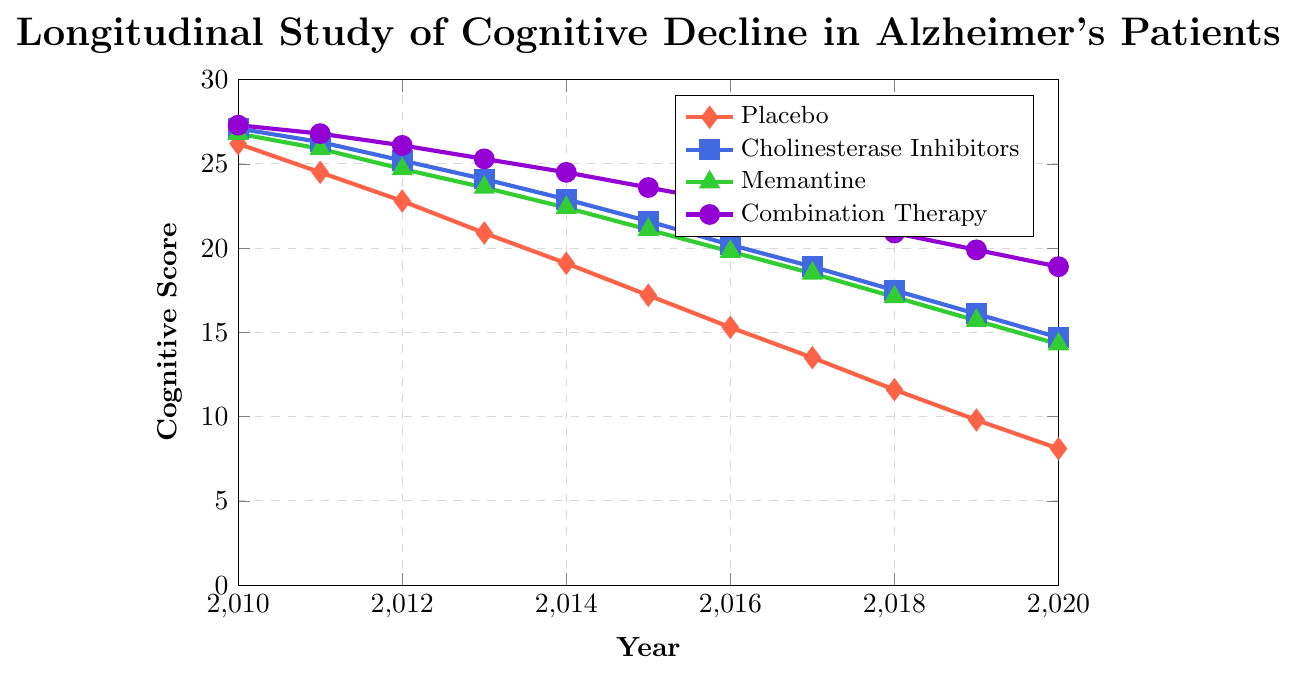Which treatment group shows the highest cognitive score in 2015? By examining the year 2015, we can compare the cognitive scores of all treatment groups: Placebo (17.2), Cholinesterase Inhibitors (21.6), Memantine (21.1), and Combination Therapy (23.6). Therefore, Combination Therapy shows the highest cognitive score.
Answer: Combination Therapy Which treatment group has the least decline in cognitive score from 2010 to 2020? Start by calculating the decline for each group: 
- Placebo: 26.2 - 8.1 = 18.1
- Cholinesterase Inhibitors: 27.1 - 14.7 = 12.4
- Memantine: 26.8 - 14.3 = 12.5
- Combination Therapy: 27.3 - 18.9 = 8.4
Combination Therapy has the least decline (8.4).
Answer: Combination Therapy During which year do Cholinesterase Inhibitors and Memantine have the same cognitive score? By comparing the cognitive scores year by year, we see all values, but none match between Cholinesterase Inhibitors and Memantine. Therefore, there is no year where they have the same score.
Answer: No year What is the average cognitive score of the Placebo group over the entire period? Sum all the cognitive scores from 2010 to 2020 and divide by the number of years: 
(26.2 + 24.5 + 22.8 + 20.9 + 19.1 + 17.2 + 15.3 + 13.5 + 11.6 + 9.8 + 8.1) / 11 = 19.08
Answer: 19.08 Which year shows the greatest decrease in cognitive score for the Cholinesterase Inhibitors group from the previous year? Calculate the difference in cognitive scores between successive years:
- 2010 to 2011: 27.1 - 26.3 = 0.8
- 2011 to 2012: 26.3 - 25.2 = 1.1
- 2012 to 2013: 25.2 - 24.1 = 1.1
- 2013 to 2014: 24.1 - 22.9 = 1.2
- 2014 to 2015: 22.9 - 21.6 = 1.3
- 2015 to 2016: 21.6 - 20.2 = 1.4
- 2016 to 2017: 20.2 - 18.9 = 1.3
- 2017 to 2018: 18.9 - 17.5 = 1.4
- 2018 to 2019: 17.5 - 16.1 = 1.4
- 2019 to 2020: 16.1 - 14.7 = 1.4
The year 2018 to 2019 has the greatest decrease of 1.4.
Answer: 2018 to 2019 What is the total cognitive score of Memantine in the years 2013 and 2014 combined? Sum the scores of Memantine in 2013 and 2014: 
23.6 (2013) + 22.4 (2014) = 46.
Answer: 46 How does the trend of the placebo group's cognitive scores compare to that of the Combination Therapy group? Visually, the Placebo group's cognitive scores show a steeper decline from 26.2 in 2010 to 8.1 in 2020. The Combination Therapy group shows a more gradual decline from 27.3 in 2010 to 18.9 in 2020. This indicates that the Placebo group experiences a more rapid cognitive decline over the years compared to the Combination Therapy group.
Answer: Steeper decline for Placebo In which year does Memantine first drop below a cognitive score of 20? By analyzing the cognitive scores for Memantine, the first year it drops below 20 is in 2016 with a score of 19.8.
Answer: 2016 